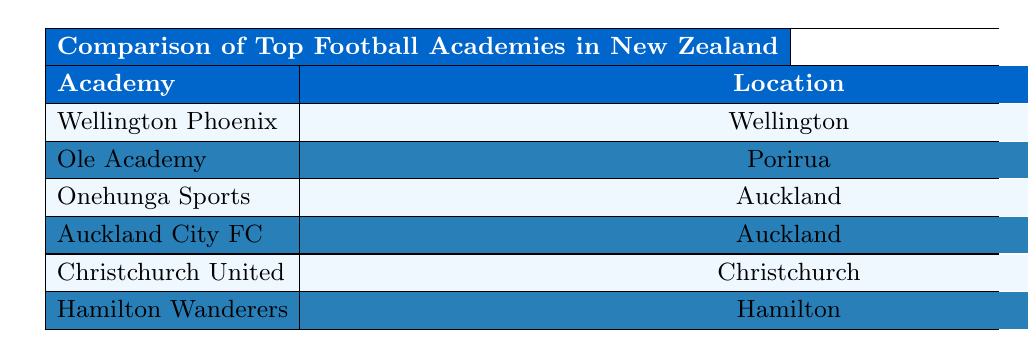What is the annual budget of the Wellington Phoenix Academy? The annual budget for Wellington Phoenix Academy is listed in the table, which shows an amount of 750,000 NZD.
Answer: 750,000 NZD Which academy has produced the most players for the national team? The table shows the number of players produced for the national team by each academy. Wellington Phoenix Academy has produced 8 players, which is the highest number.
Answer: Wellington Phoenix Academy What is the average age of graduates from the Auckland City FC Academy? The average age of graduates from Auckland City FC Academy is clearly stated in the table as 18.9 years.
Answer: 18.9 years How many players have been signed to pro clubs by the Ole Academy? The Ole Academy has had 18 players signed to pro clubs, as indicated in the table.
Answer: 18 players What is the difference in the number of players signed to pro clubs between Wellington Phoenix Academy and Christchurch United Academy? Wellington Phoenix Academy has 23 players signed to pro clubs, while Christchurch United Academy has 9. The difference between them is 23 - 9 = 14.
Answer: 14 players Which academy has the highest facilities rating? The facilities rating for each academy is listed; Wellington Phoenix Academy has a facilities rating of 8.5, which is the highest score in the table.
Answer: Wellington Phoenix Academy What is the total number of domestic titles won by Onehunga Sports Academy and Hamilton Wanderers Academy combined? Onehunga Sports Academy has won 1 domestic title and Hamilton Wanderers Academy has also won 1, so the total is 1 + 1 = 2 domestic titles combined.
Answer: 2 domestic titles Is it true that Christchurch United Academy has more players signed to pro clubs than Onehunga Sports Academy? Christchurch United Academy has 9 players signed to pro clubs, while Onehunga Sports Academy has 12. Since 9 is less than 12, this statement is false.
Answer: No Which academy is the youngest in terms of establishment year? The youngest academy is Christchurch United Academy, established in 2015, as per the data provided in the table.
Answer: Christchurch United Academy Calculate the average annual budget of all the academies listed. The annual budgets are 750,000, 500,000, 350,000, 600,000, 300,000, and 400,000 NZD. The total is 750,000 + 500,000 + 350,000 + 600,000 + 300,000 + 400,000 = 2,900,000 NZD. Dividing by the number of academies (6), the average annual budget is 2,900,000 / 6 ≈ 483,333.33 NZD.
Answer: 483,333.33 NZD 